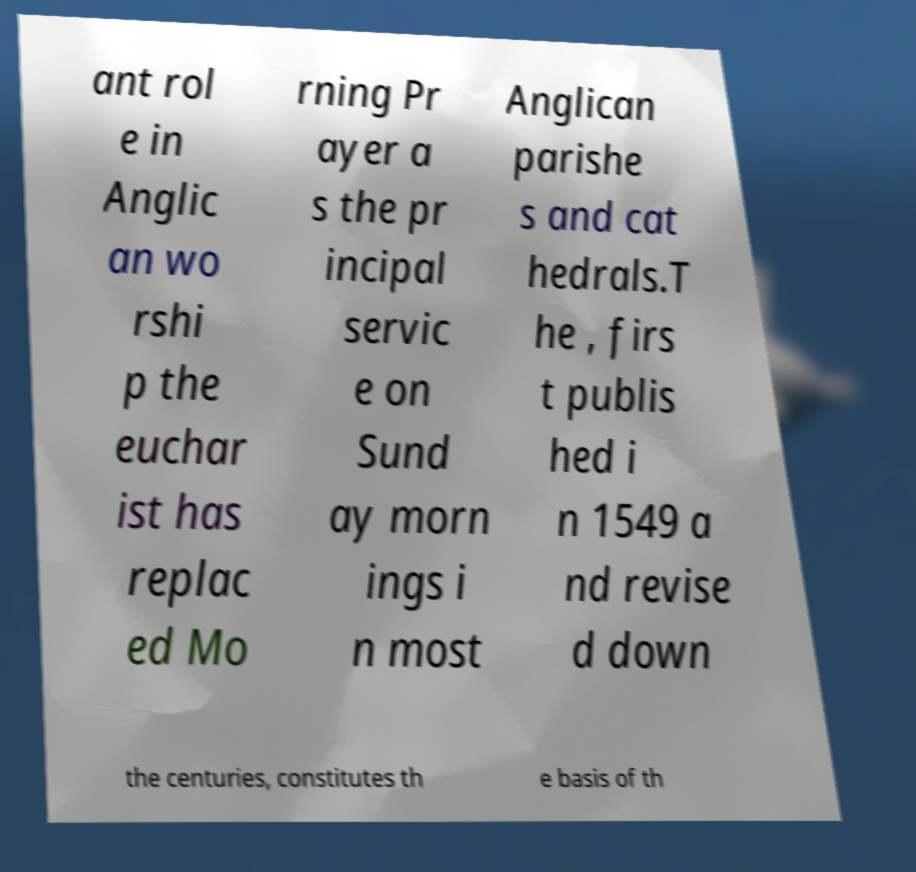Please identify and transcribe the text found in this image. ant rol e in Anglic an wo rshi p the euchar ist has replac ed Mo rning Pr ayer a s the pr incipal servic e on Sund ay morn ings i n most Anglican parishe s and cat hedrals.T he , firs t publis hed i n 1549 a nd revise d down the centuries, constitutes th e basis of th 